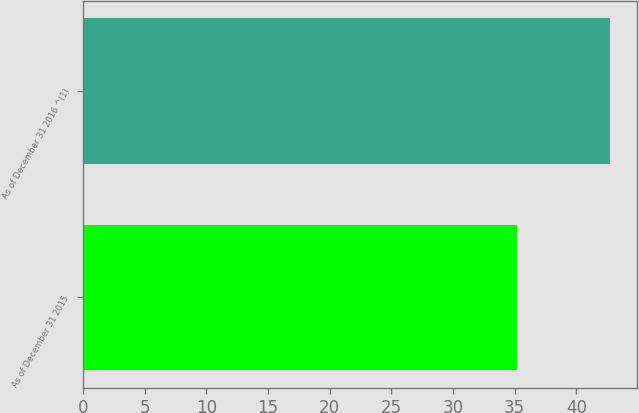Convert chart. <chart><loc_0><loc_0><loc_500><loc_500><bar_chart><fcel>As of December 31 2015<fcel>As of December 31 2016 ^(1)<nl><fcel>35.19<fcel>42.77<nl></chart> 